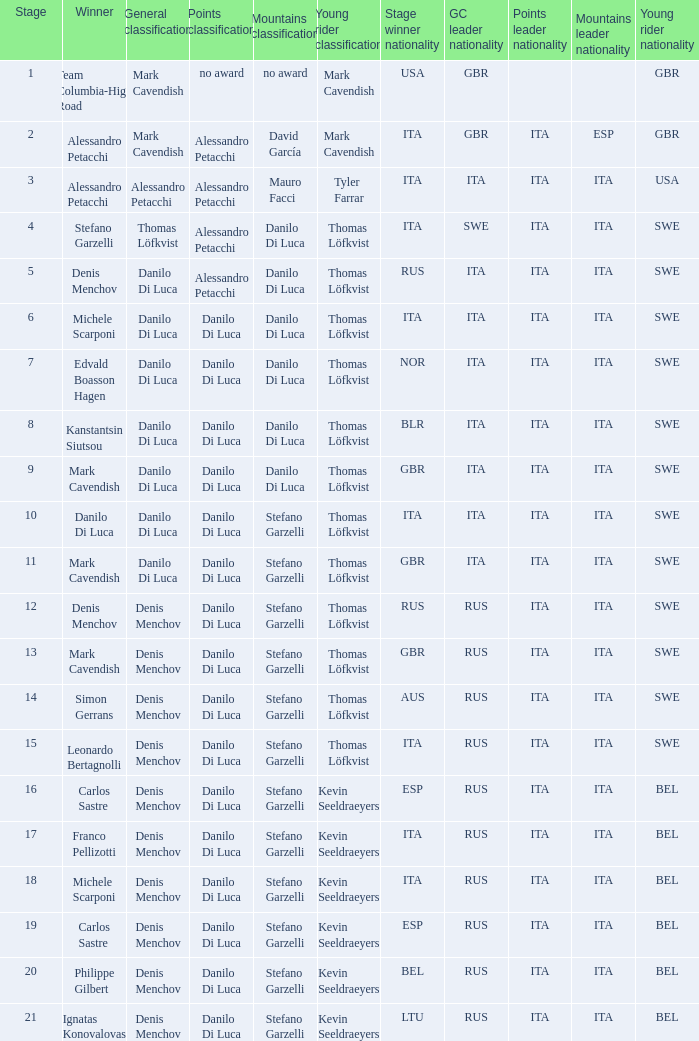When danilo di luca is the winner who is the general classification?  Danilo Di Luca. 